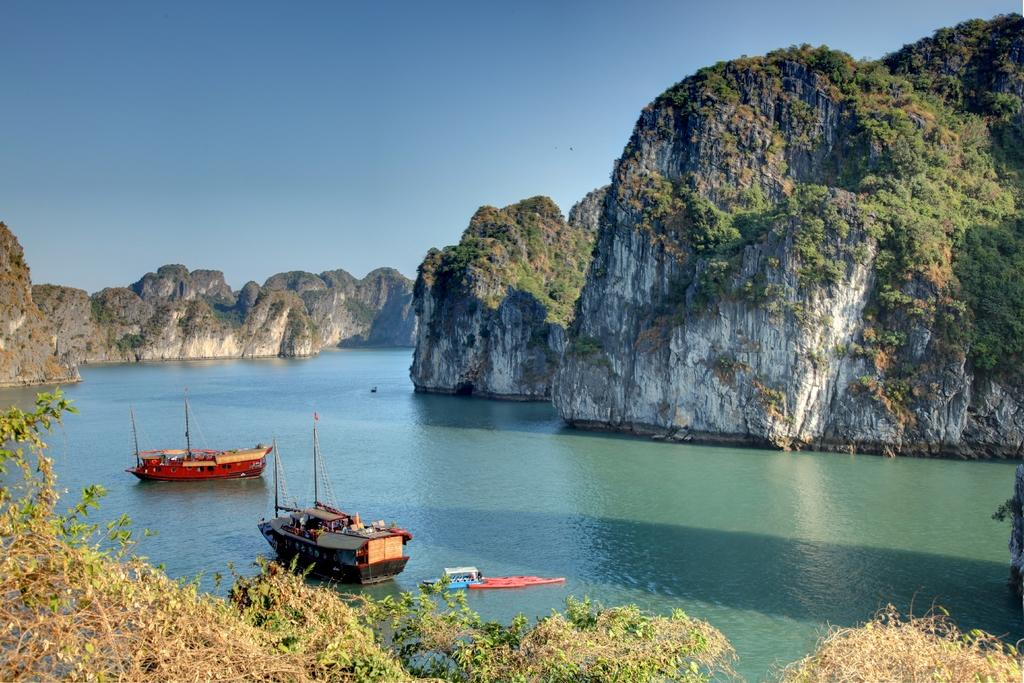How many boats can be seen in the water in the image? There are three boats in the water in the image. What is located in the foreground of the image? There is a group of trees in the foreground. What is visible in the background of the image? There is a group of mountains and the sky in the background. What type of air is being used to power the boats in the image? The boats in the image are not powered by air; they are likely powered by engines or sails. How does the health of the trees in the foreground affect the image? The health of the trees in the foreground does not affect the image, as the image is a static representation and not a living ecosystem. 